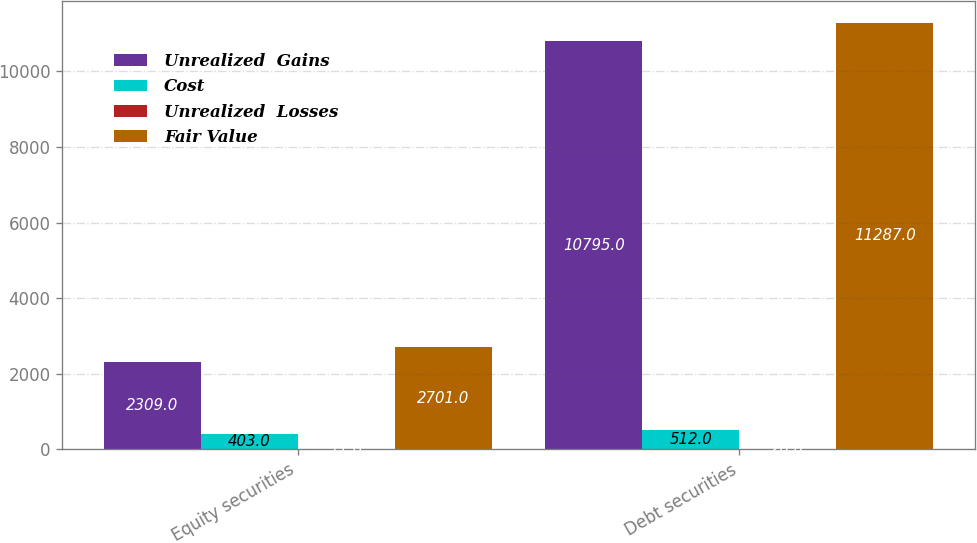Convert chart. <chart><loc_0><loc_0><loc_500><loc_500><stacked_bar_chart><ecel><fcel>Equity securities<fcel>Debt securities<nl><fcel>Unrealized  Gains<fcel>2309<fcel>10795<nl><fcel>Cost<fcel>403<fcel>512<nl><fcel>Unrealized  Losses<fcel>11<fcel>20<nl><fcel>Fair Value<fcel>2701<fcel>11287<nl></chart> 